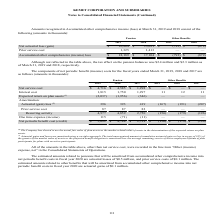From Kemet Corporation's financial document, Which years does the table provide information for Amounts recognized in Accumulated other comprehensive income (loss)? The document shows two values: 2019 and 2018. From the document: "2019 2018 2019 2018 2019 2018 2019 2018..." Also, What was the prior service cost for Pension in 2019? According to the financial document, 1,325 (in thousands). The relevant text states: "Prior service cost 1,325 1,413 — —..." Also, What was the Net actuarial loss (gain) for Other Benefits in 2018? According to the financial document, (879) (in thousands). The relevant text states: "actuarial loss (gain) $ 16,864 $ 15,691 $ (793) $ (879)..." Also, can you calculate: What was the change in the Net actuarial loss  for Other Benefits between 2018 and 2019? Based on the calculation: -793-(-879), the result is 86. This is based on the information: "Net actuarial loss (gain) $ 16,864 $ 15,691 $ (793) $ (879) ctuarial loss (gain) $ 16,864 $ 15,691 $ (793) $ (879)..." The key data points involved are: 793, 879. Also, can you calculate: What was the change in the Accumulated other comprehensive (income) loss for Pension between 2018 and 2019? Based on the calculation: 18,189-17,104, the result is 1085 (in thousands). This is based on the information: "Accumulated other comprehensive (income) loss $ 18,189 $ 17,104 $ (793) $ (879) ated other comprehensive (income) loss $ 18,189 $ 17,104 $ (793) $ (879)..." The key data points involved are: 17,104, 18,189. Also, can you calculate: What was the percentage change in the prior service cost for Pension between 2018 and 2019? To answer this question, I need to perform calculations using the financial data. The calculation is: (1,325-1,413)/1,413, which equals -6.23 (percentage). This is based on the information: "Prior service cost 1,325 1,413 — — Prior service cost 1,325 1,413 — —..." The key data points involved are: 1,325, 1,413. 